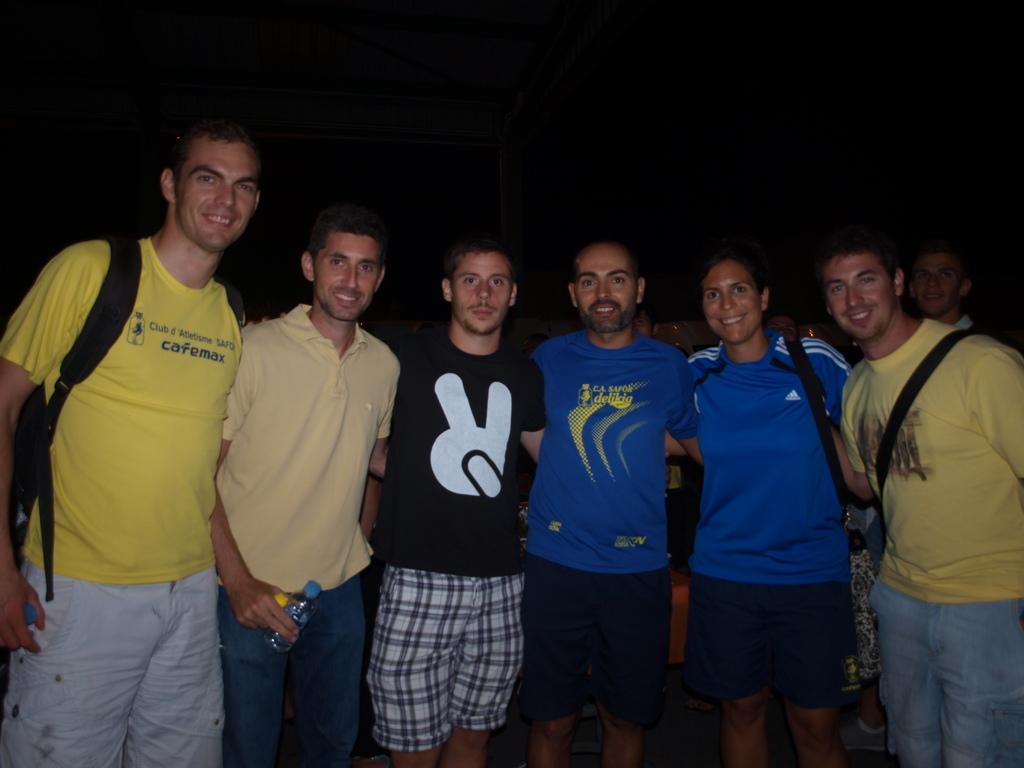How would you summarize this image in a sentence or two? In this image, we can see a group of people are standing, seeing and smiling. Here we can see few people are wearing bags and holding some objects. Background there is a dark view. 